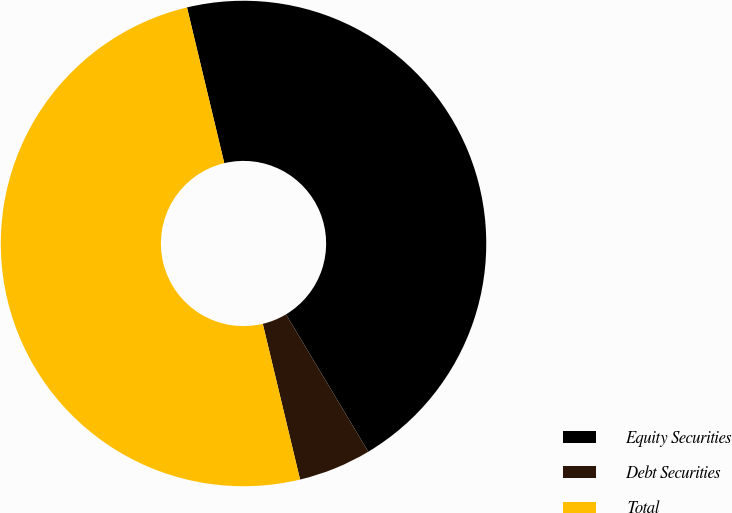<chart> <loc_0><loc_0><loc_500><loc_500><pie_chart><fcel>Equity Securities<fcel>Debt Securities<fcel>Total<nl><fcel>45.15%<fcel>4.85%<fcel>50.0%<nl></chart> 